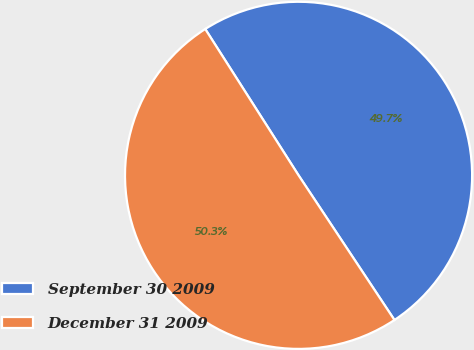Convert chart. <chart><loc_0><loc_0><loc_500><loc_500><pie_chart><fcel>September 30 2009<fcel>December 31 2009<nl><fcel>49.72%<fcel>50.28%<nl></chart> 